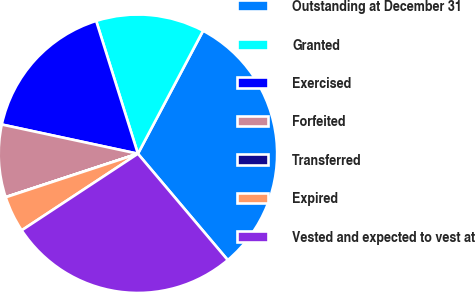Convert chart to OTSL. <chart><loc_0><loc_0><loc_500><loc_500><pie_chart><fcel>Outstanding at December 31<fcel>Granted<fcel>Exercised<fcel>Forfeited<fcel>Transferred<fcel>Expired<fcel>Vested and expected to vest at<nl><fcel>31.08%<fcel>12.6%<fcel>16.79%<fcel>8.41%<fcel>0.02%<fcel>4.21%<fcel>26.89%<nl></chart> 